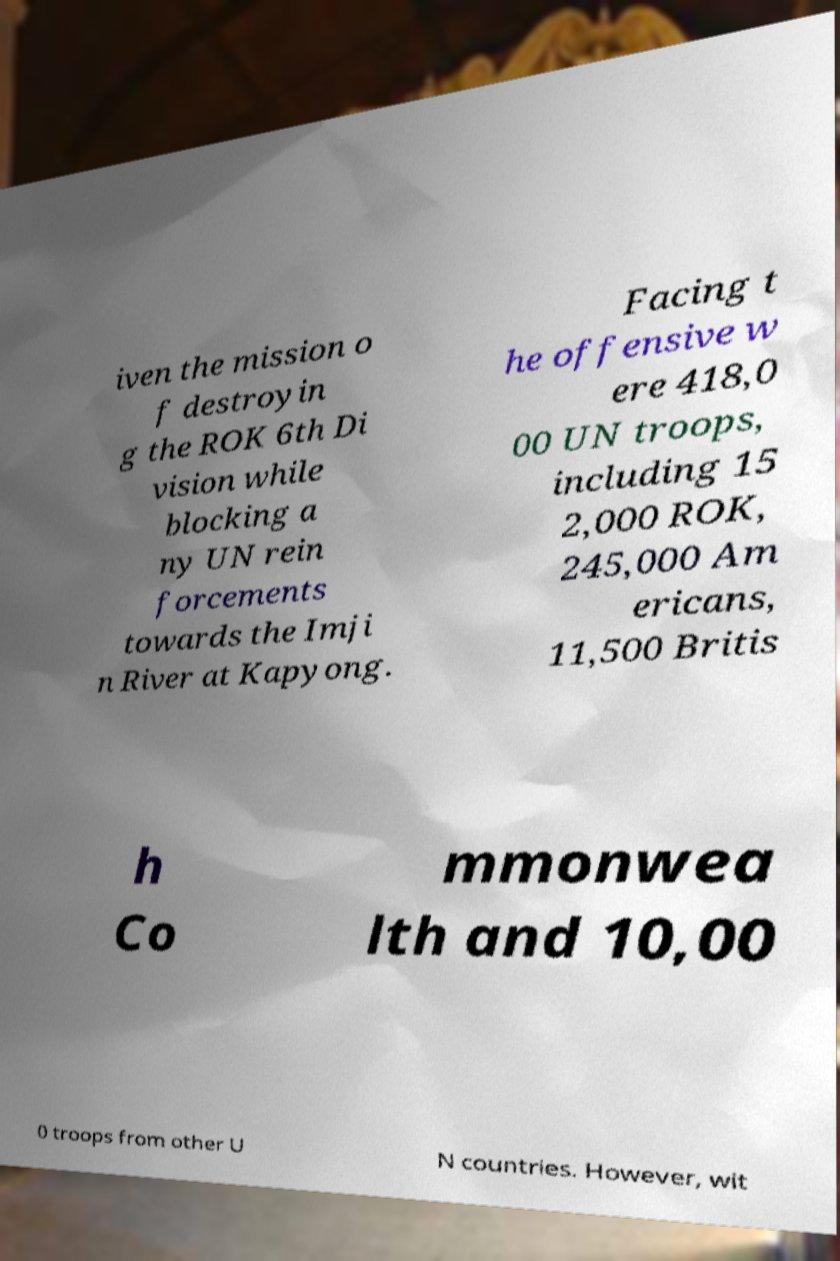Please read and relay the text visible in this image. What does it say? iven the mission o f destroyin g the ROK 6th Di vision while blocking a ny UN rein forcements towards the Imji n River at Kapyong. Facing t he offensive w ere 418,0 00 UN troops, including 15 2,000 ROK, 245,000 Am ericans, 11,500 Britis h Co mmonwea lth and 10,00 0 troops from other U N countries. However, wit 